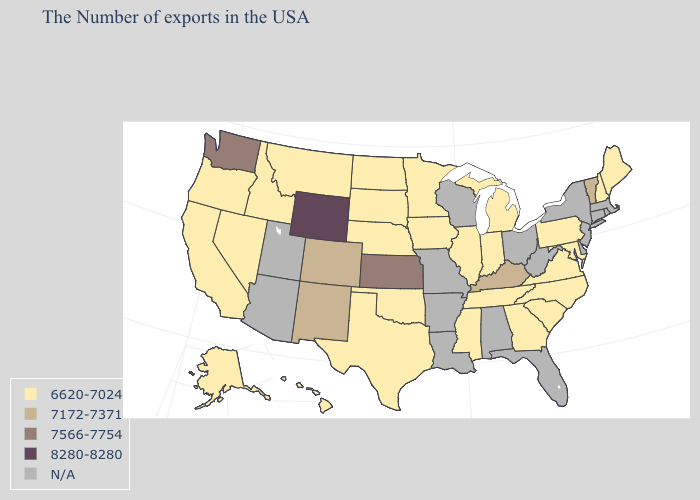What is the highest value in states that border North Dakota?
Short answer required. 6620-7024. Is the legend a continuous bar?
Concise answer only. No. Among the states that border Missouri , which have the highest value?
Short answer required. Kansas. Among the states that border Illinois , which have the highest value?
Write a very short answer. Kentucky. Which states have the lowest value in the South?
Give a very brief answer. Maryland, Virginia, North Carolina, South Carolina, Georgia, Tennessee, Mississippi, Oklahoma, Texas. What is the value of Wyoming?
Give a very brief answer. 8280-8280. Among the states that border Wyoming , does Colorado have the lowest value?
Give a very brief answer. No. What is the value of North Carolina?
Write a very short answer. 6620-7024. What is the value of Illinois?
Keep it brief. 6620-7024. Does Kansas have the lowest value in the USA?
Short answer required. No. Is the legend a continuous bar?
Concise answer only. No. Does the first symbol in the legend represent the smallest category?
Keep it brief. Yes. Does Wyoming have the highest value in the USA?
Short answer required. Yes. Name the states that have a value in the range 8280-8280?
Concise answer only. Wyoming. 